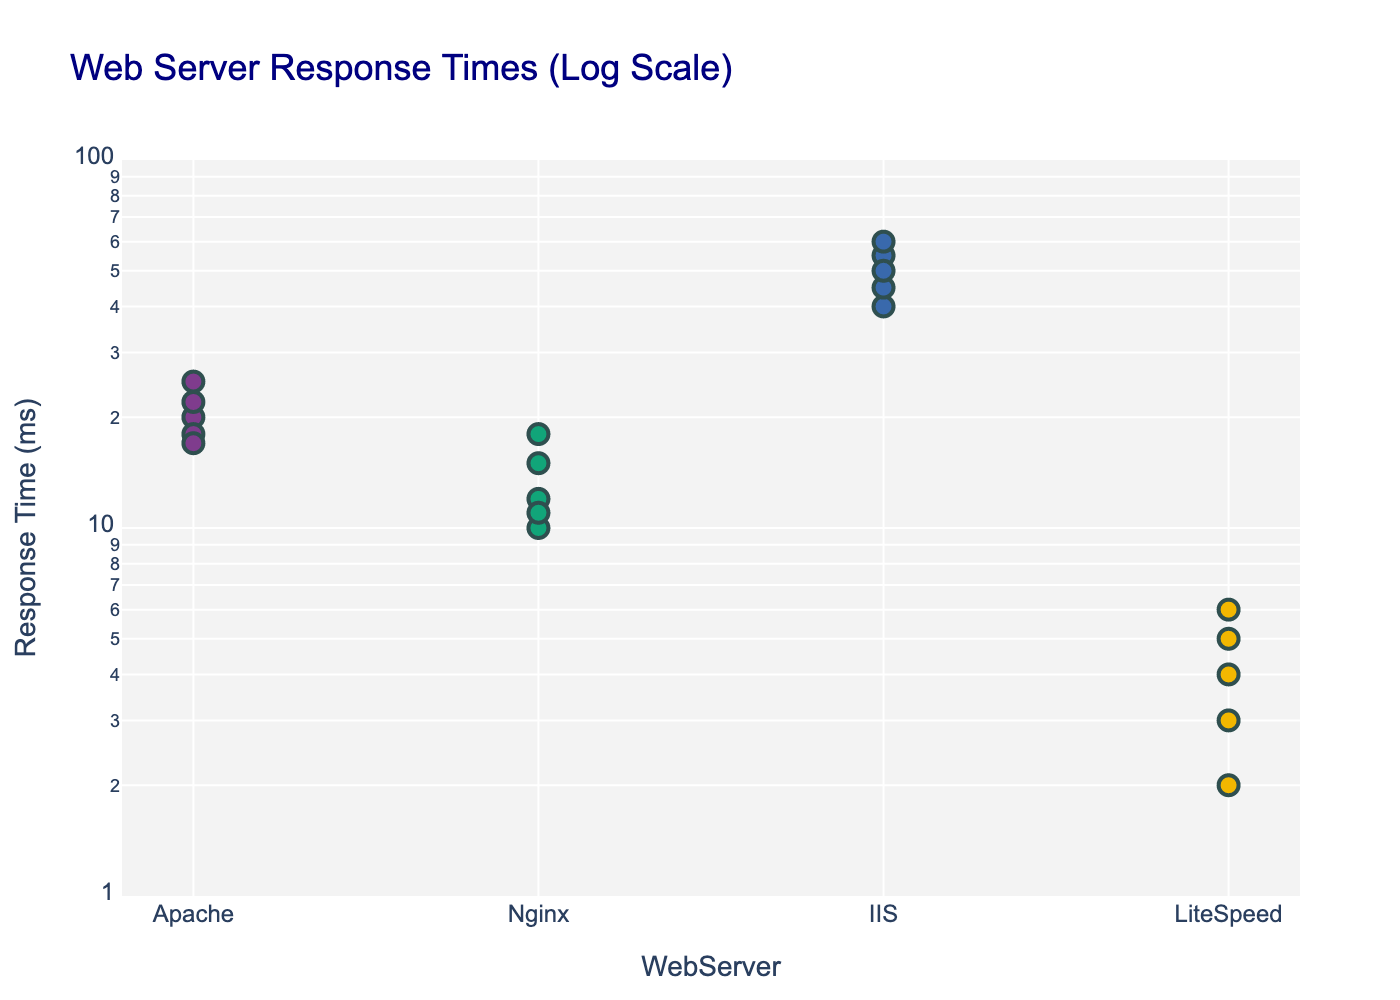What's the title of the plot? The title is located at the top center of the figure. It provides a brief description of what the plot represents.
Answer: Web Server Response Times (Log Scale) Which web server has the lowest response time? By looking at the y-axis values on the plot, we can see which web server has the lowest (smallest) value. The smallest value is at the bottom of the y-axis, and the corresponding web server can be found on the x-axis.
Answer: LiteSpeed How many data points are there for Apache? Count the number of scatter points for the web server "Apache" on the plot. Each point represents a data point.
Answer: 5 What is the mean response time for Nginx as shown in the plot? The mean response time is annotated on the plot. Locate the annotation text for Nginx.
Answer: 13.2ms Which web server has the highest mean response time? Compare the annotated mean response times for all web servers on the plot. The highest value will indicate the web server with the highest mean response time.
Answer: IIS How does the mean response time of Apache compare to LiteSpeed? Check the annotated mean response times for both Apache and LiteSpeed. Determine if Apache's mean is greater than, less than, or equal to that of LiteSpeed.
Answer: Apache's mean is higher What range of response times is displayed on the y-axis? The y-axis value range is indicated by the axis limits. Since it is a log scale, the values typically range from 10^x to 10^y.
Answer: From 10^-1 to 10^2 ms Which web server shows the most variability in response times? Look at the spread of data points for each web server. The web server with points furthest apart and/or the largest range will have the most variability.
Answer: IIS What response time range do most LiteSpeed data points fall within? Observe the distribution of data points for LiteSpeed on the y-axis. Most points indicate the range.
Answer: 2-6 ms Is there any overlap in response times between Nginx and Apache? Check if any data points for Nginx are at the same y-axis values as any data points for Apache.
Answer: Yes 